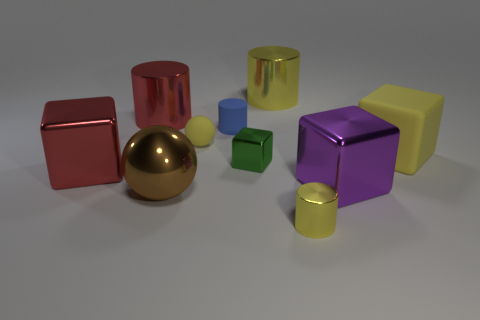Subtract all cylinders. How many objects are left? 6 Subtract 1 yellow balls. How many objects are left? 9 Subtract all large yellow cylinders. Subtract all red shiny blocks. How many objects are left? 8 Add 2 big red shiny blocks. How many big red shiny blocks are left? 3 Add 8 gray shiny blocks. How many gray shiny blocks exist? 8 